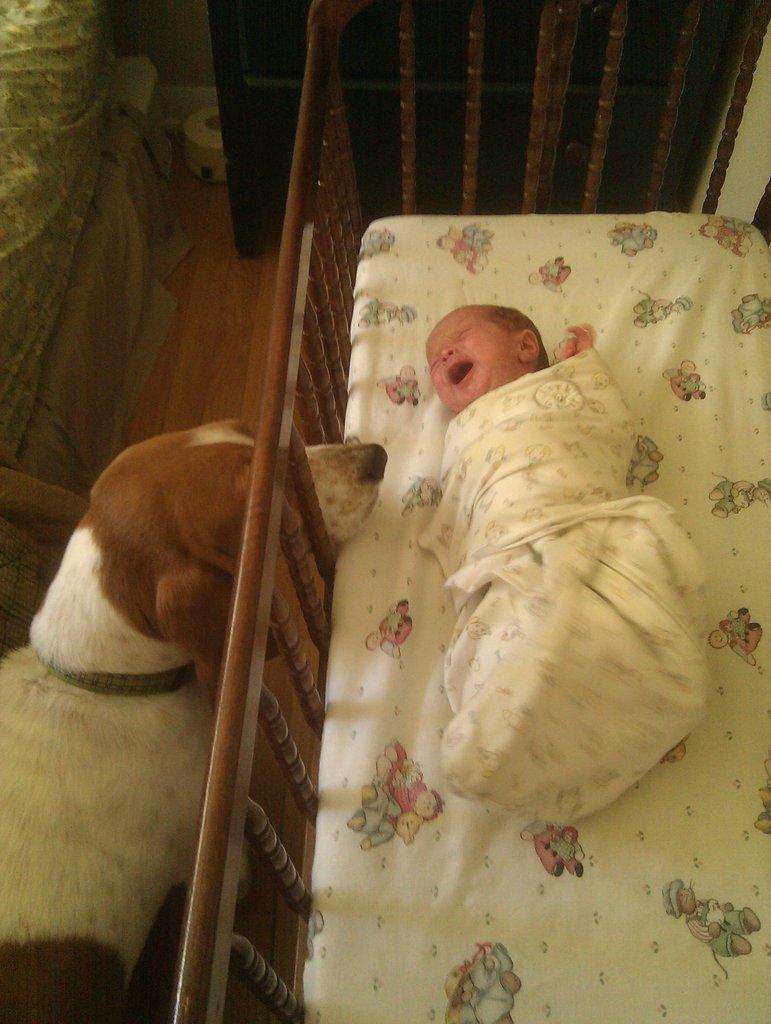How would you summarize this image in a sentence or two? In this image I can see a baby is laying in the cradle and I can see the cream colored cloth around the baby. I can see the dog which is brown, cream and black in color is standing on the floor. I can see few objects which are black, white and green in color in the background. 